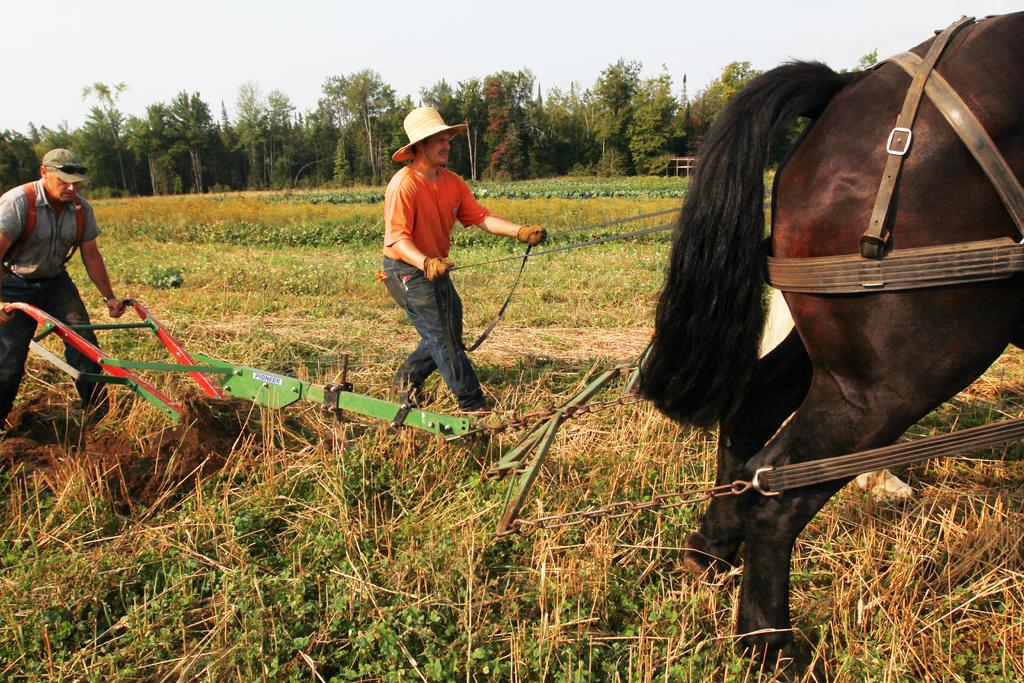How many people are present in the image? There are two people in the image. What are the people doing in the image? The people are farming in an agricultural field. What type of vegetation can be seen in the image? There are trees in the image. What animal is present in the image? There is a horse in the image. What part of the natural environment is visible in the image? The sky is visible in the image. What type of authority figure can be seen in the image? There is no authority figure present in the image; it features two people farming in an agricultural field. What type of cherry is being picked by the people in the image? There is no cherry present in the image; the people are farming in an agricultural field, but no specific crop is mentioned or depicted. 